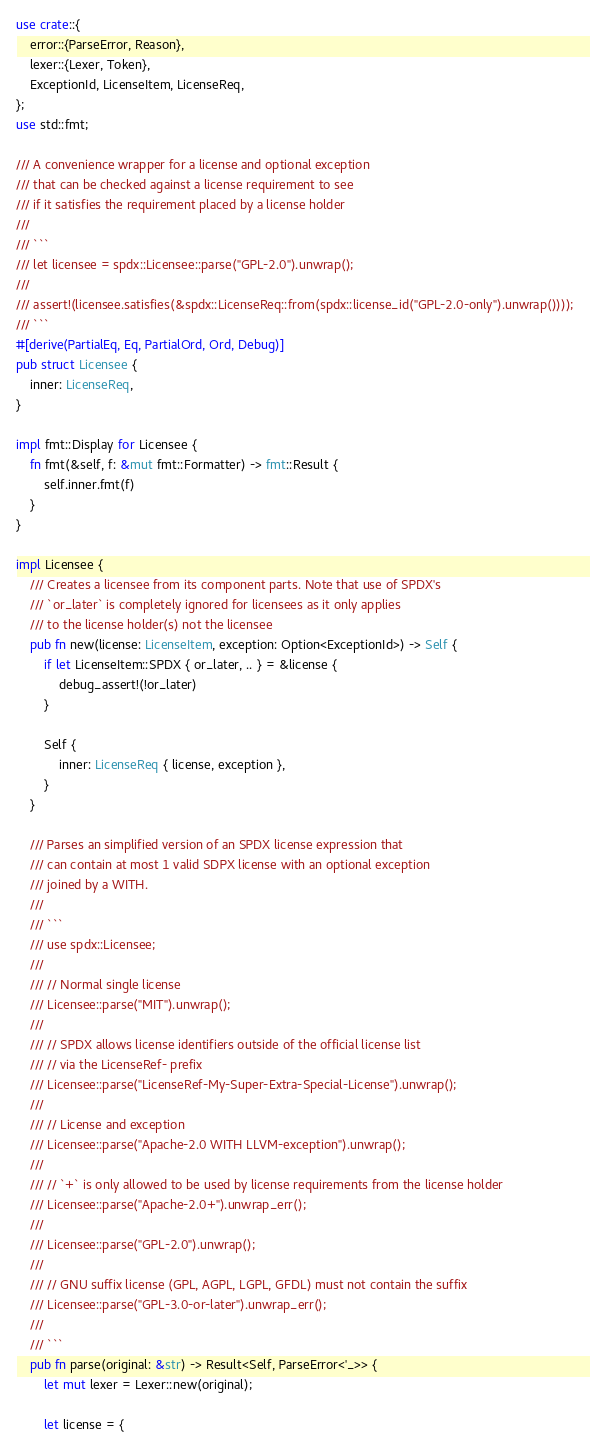<code> <loc_0><loc_0><loc_500><loc_500><_Rust_>use crate::{
    error::{ParseError, Reason},
    lexer::{Lexer, Token},
    ExceptionId, LicenseItem, LicenseReq,
};
use std::fmt;

/// A convenience wrapper for a license and optional exception
/// that can be checked against a license requirement to see
/// if it satisfies the requirement placed by a license holder
///
/// ```
/// let licensee = spdx::Licensee::parse("GPL-2.0").unwrap();
///
/// assert!(licensee.satisfies(&spdx::LicenseReq::from(spdx::license_id("GPL-2.0-only").unwrap())));
/// ```
#[derive(PartialEq, Eq, PartialOrd, Ord, Debug)]
pub struct Licensee {
    inner: LicenseReq,
}

impl fmt::Display for Licensee {
    fn fmt(&self, f: &mut fmt::Formatter) -> fmt::Result {
        self.inner.fmt(f)
    }
}

impl Licensee {
    /// Creates a licensee from its component parts. Note that use of SPDX's
    /// `or_later` is completely ignored for licensees as it only applies
    /// to the license holder(s) not the licensee
    pub fn new(license: LicenseItem, exception: Option<ExceptionId>) -> Self {
        if let LicenseItem::SPDX { or_later, .. } = &license {
            debug_assert!(!or_later)
        }

        Self {
            inner: LicenseReq { license, exception },
        }
    }

    /// Parses an simplified version of an SPDX license expression that
    /// can contain at most 1 valid SDPX license with an optional exception
    /// joined by a WITH.
    ///
    /// ```
    /// use spdx::Licensee;
    ///
    /// // Normal single license
    /// Licensee::parse("MIT").unwrap();
    ///
    /// // SPDX allows license identifiers outside of the official license list
    /// // via the LicenseRef- prefix
    /// Licensee::parse("LicenseRef-My-Super-Extra-Special-License").unwrap();
    ///
    /// // License and exception
    /// Licensee::parse("Apache-2.0 WITH LLVM-exception").unwrap();
    ///
    /// // `+` is only allowed to be used by license requirements from the license holder
    /// Licensee::parse("Apache-2.0+").unwrap_err();
    ///
    /// Licensee::parse("GPL-2.0").unwrap();
    ///
    /// // GNU suffix license (GPL, AGPL, LGPL, GFDL) must not contain the suffix
    /// Licensee::parse("GPL-3.0-or-later").unwrap_err();
    ///
    /// ```
    pub fn parse(original: &str) -> Result<Self, ParseError<'_>> {
        let mut lexer = Lexer::new(original);

        let license = {</code> 